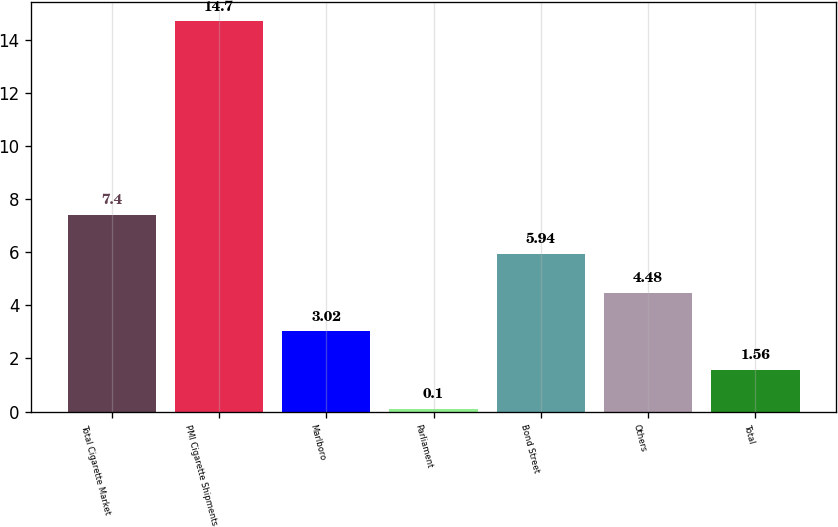Convert chart to OTSL. <chart><loc_0><loc_0><loc_500><loc_500><bar_chart><fcel>Total Cigarette Market<fcel>PMI Cigarette Shipments<fcel>Marlboro<fcel>Parliament<fcel>Bond Street<fcel>Others<fcel>Total<nl><fcel>7.4<fcel>14.7<fcel>3.02<fcel>0.1<fcel>5.94<fcel>4.48<fcel>1.56<nl></chart> 